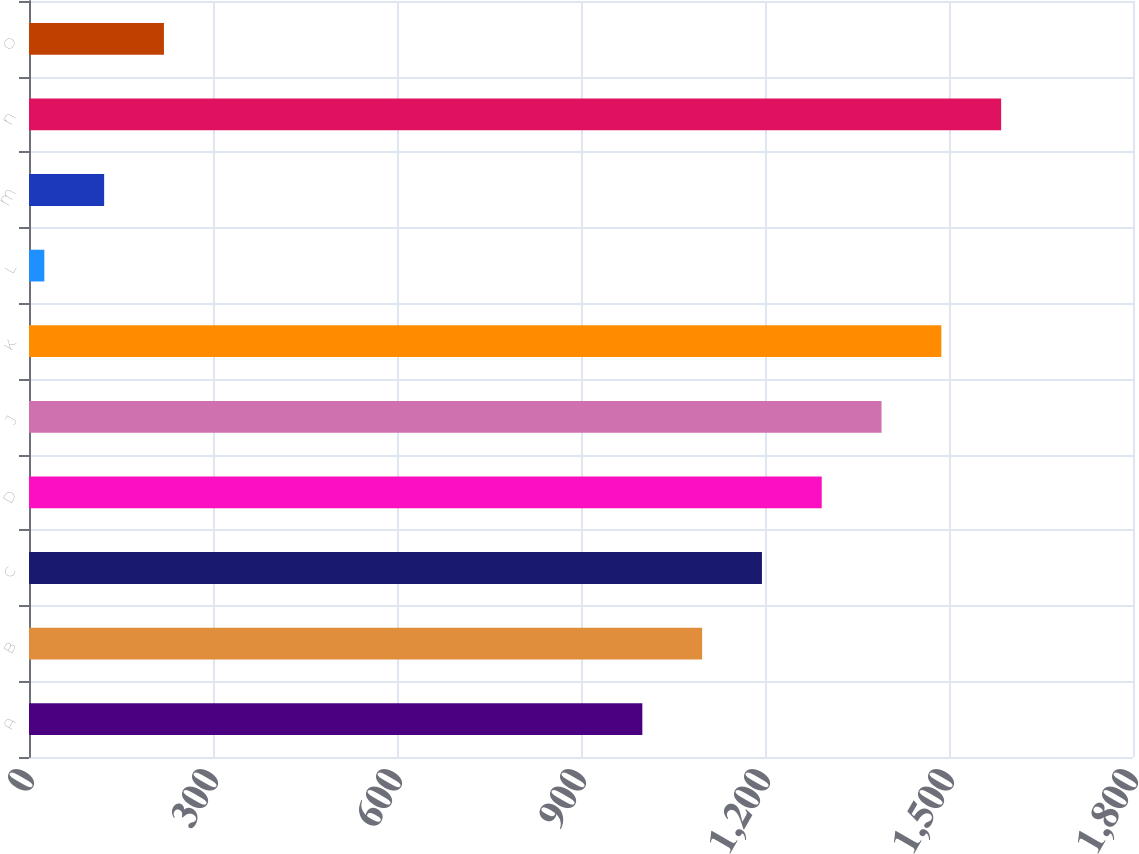<chart> <loc_0><loc_0><loc_500><loc_500><bar_chart><fcel>A<fcel>B<fcel>C<fcel>D<fcel>J<fcel>K<fcel>L<fcel>M<fcel>N<fcel>O<nl><fcel>1000<fcel>1097.5<fcel>1195<fcel>1292.5<fcel>1390<fcel>1487.5<fcel>25<fcel>122.5<fcel>1585<fcel>220<nl></chart> 